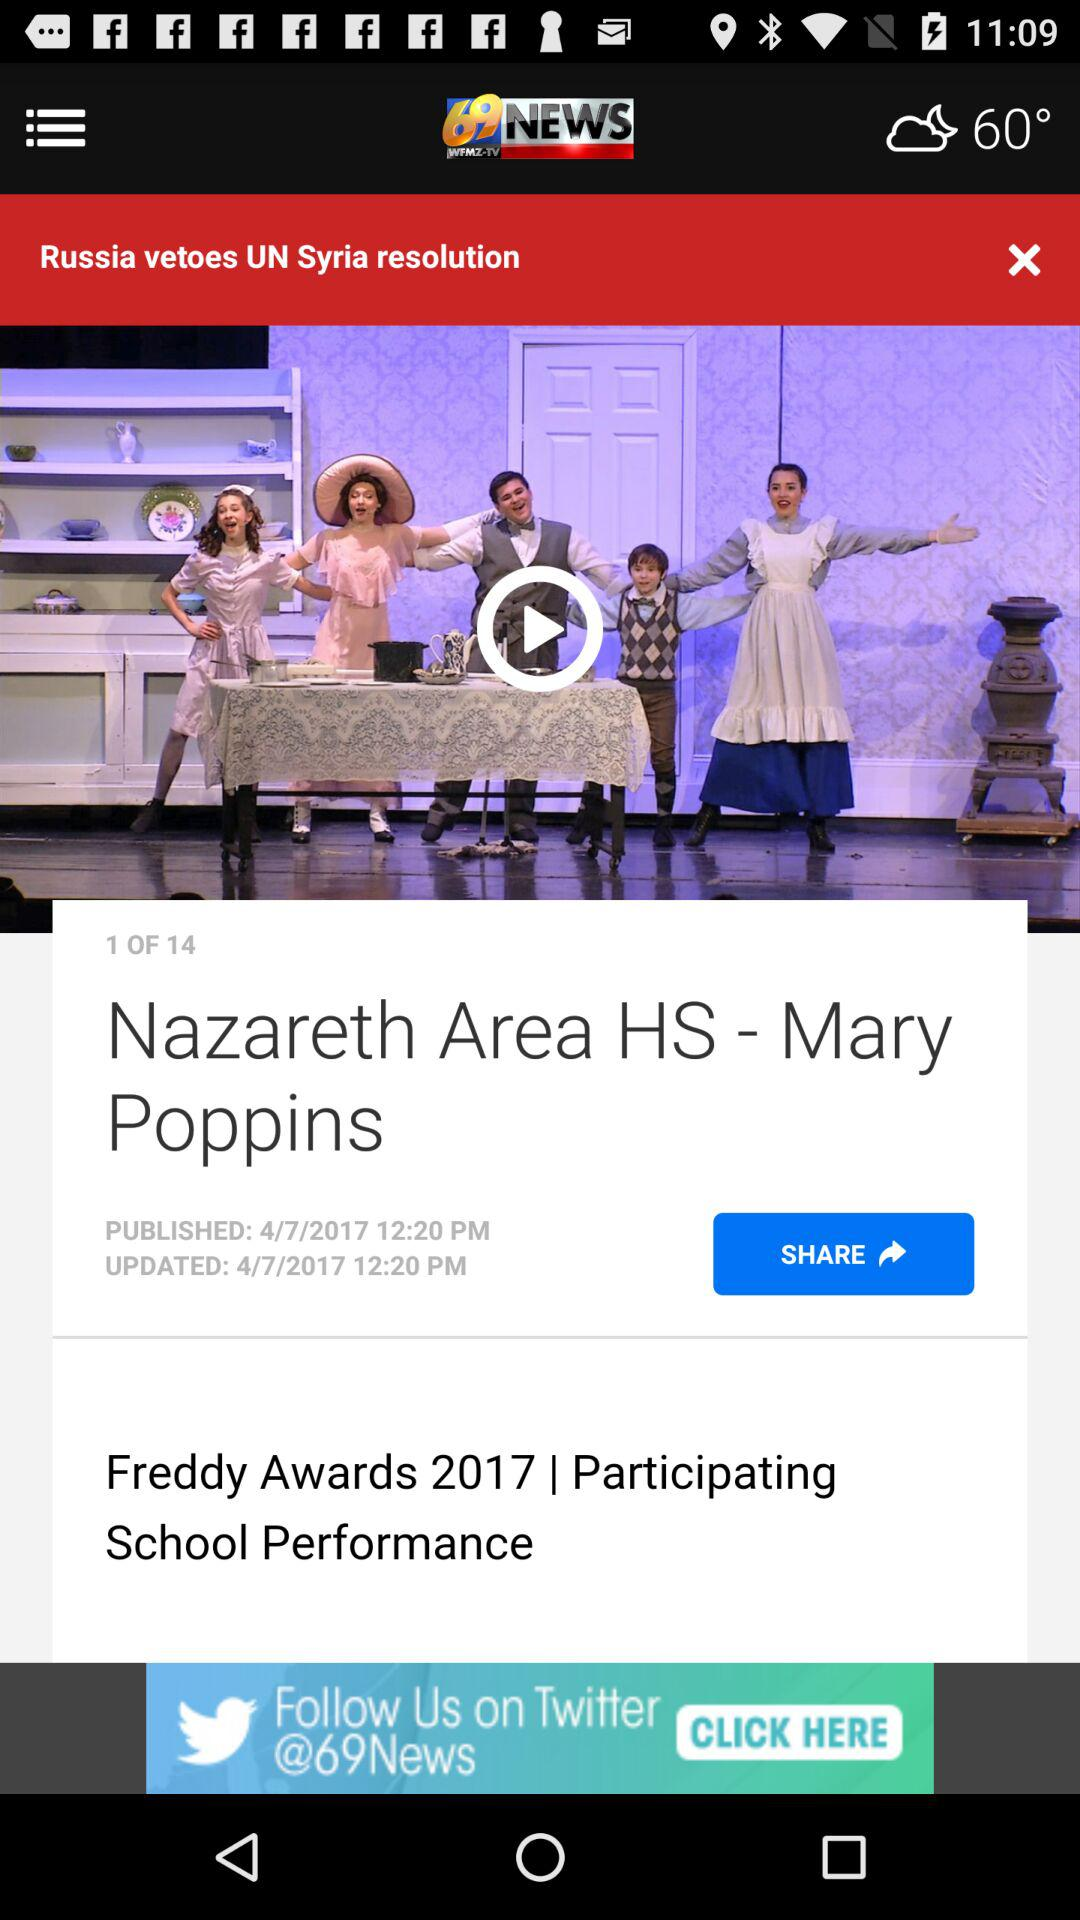What is the news channel name? The news channel name is "69 NEWS". 